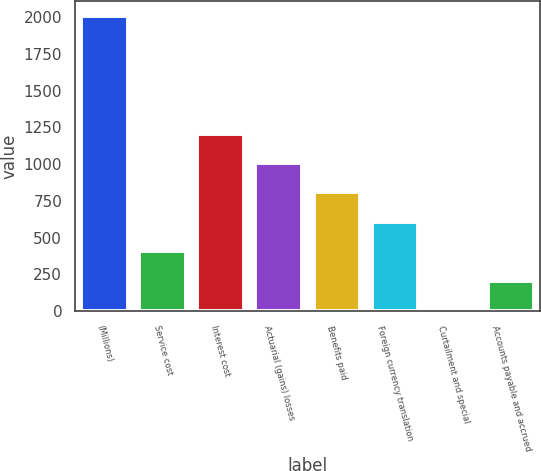Convert chart. <chart><loc_0><loc_0><loc_500><loc_500><bar_chart><fcel>(Millions)<fcel>Service cost<fcel>Interest cost<fcel>Actuarial (gains) losses<fcel>Benefits paid<fcel>Foreign currency translation<fcel>Curtailment and special<fcel>Accounts payable and accrued<nl><fcel>2007<fcel>407<fcel>1207<fcel>1007<fcel>807<fcel>607<fcel>7<fcel>207<nl></chart> 